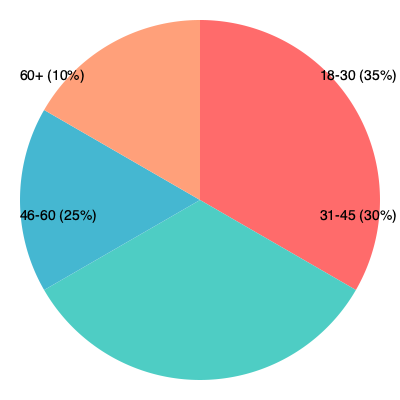Based on the pie chart depicting the age distribution of Mykola Babenko's supporters, which age group shows the highest percentage of support, and what percentage of supporters are under the age of 46? To answer this question, we need to analyze the pie chart and perform some calculations:

1. Identify the highest percentage:
   - 18-30: 35%
   - 31-45: 30%
   - 46-60: 25%
   - 60+: 10%
   The highest percentage is 35%, corresponding to the 18-30 age group.

2. Calculate the percentage of supporters under 46:
   - This includes the 18-30 and 31-45 age groups
   - 18-30: 35%
   - 31-45: 30%
   - Sum: 35% + 30% = 65%

Therefore, the age group with the highest percentage of support is 18-30, and 65% of supporters are under the age of 46.
Answer: 18-30; 65% 